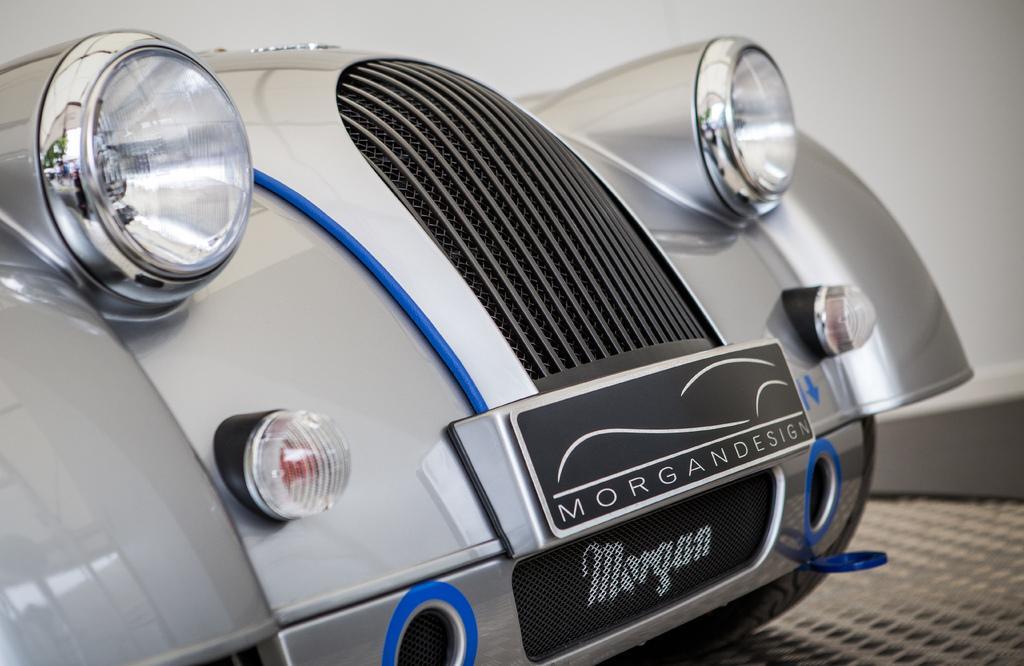Can you describe this image briefly? This is a picture of a front part of the car , which is on the path. 